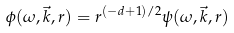Convert formula to latex. <formula><loc_0><loc_0><loc_500><loc_500>\phi ( \omega , \vec { k } , r ) = r ^ { ( - d + 1 ) / 2 } \psi ( \omega , \vec { k } , r )</formula> 